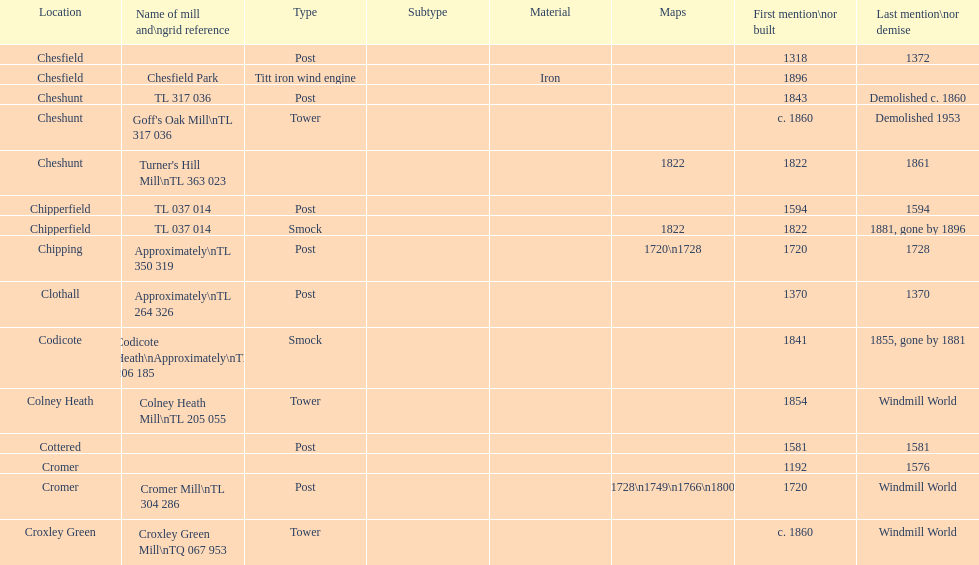How many mills were mentioned or built before 1700? 5. Parse the table in full. {'header': ['Location', 'Name of mill and\\ngrid reference', 'Type', 'Subtype', 'Material', 'Maps', 'First mention\\nor built', 'Last mention\\nor demise'], 'rows': [['Chesfield', '', 'Post', '', '', '', '1318', '1372'], ['Chesfield', 'Chesfield Park', 'Titt iron wind engine', '', 'Iron', '', '1896', ''], ['Cheshunt', 'TL 317 036', 'Post', '', '', '', '1843', 'Demolished c. 1860'], ['Cheshunt', "Goff's Oak Mill\\nTL 317 036", 'Tower', '', '', '', 'c. 1860', 'Demolished 1953'], ['Cheshunt', "Turner's Hill Mill\\nTL 363 023", '', '', '', '1822', '1822', '1861'], ['Chipperfield', 'TL 037 014', 'Post', '', '', '', '1594', '1594'], ['Chipperfield', 'TL 037 014', 'Smock', '', '', '1822', '1822', '1881, gone by 1896'], ['Chipping', 'Approximately\\nTL 350 319', 'Post', '', '', '1720\\n1728', '1720', '1728'], ['Clothall', 'Approximately\\nTL 264 326', 'Post', '', '', '', '1370', '1370'], ['Codicote', 'Codicote Heath\\nApproximately\\nTL 206 185', 'Smock', '', '', '', '1841', '1855, gone by 1881'], ['Colney Heath', 'Colney Heath Mill\\nTL 205 055', 'Tower', '', '', '', '1854', 'Windmill World'], ['Cottered', '', 'Post', '', '', '', '1581', '1581'], ['Cromer', '', '', '', '', '', '1192', '1576'], ['Cromer', 'Cromer Mill\\nTL 304 286', 'Post', '', '', '1720\\n1728\\n1749\\n1766\\n1800\\n1822', '1720', 'Windmill World'], ['Croxley Green', 'Croxley Green Mill\\nTQ 067 953', 'Tower', '', '', '', 'c. 1860', 'Windmill World']]} 